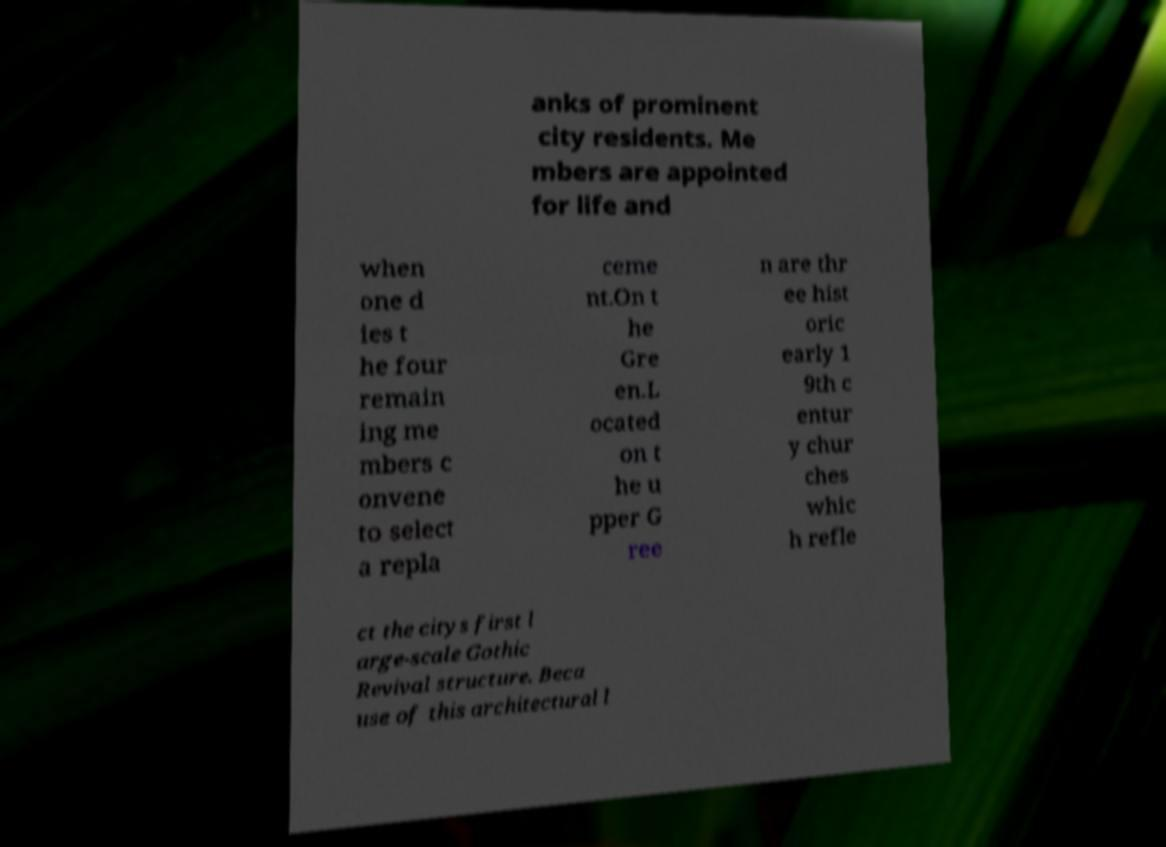Please identify and transcribe the text found in this image. anks of prominent city residents. Me mbers are appointed for life and when one d ies t he four remain ing me mbers c onvene to select a repla ceme nt.On t he Gre en.L ocated on t he u pper G ree n are thr ee hist oric early 1 9th c entur y chur ches whic h refle ct the citys first l arge-scale Gothic Revival structure. Beca use of this architectural l 